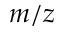<formula> <loc_0><loc_0><loc_500><loc_500>m / z</formula> 